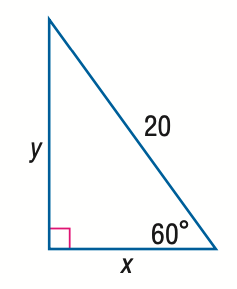Answer the mathemtical geometry problem and directly provide the correct option letter.
Question: Find y.
Choices: A: 10 B: 10 \sqrt { 2 } C: 10 \sqrt { 3 } D: 20 C 